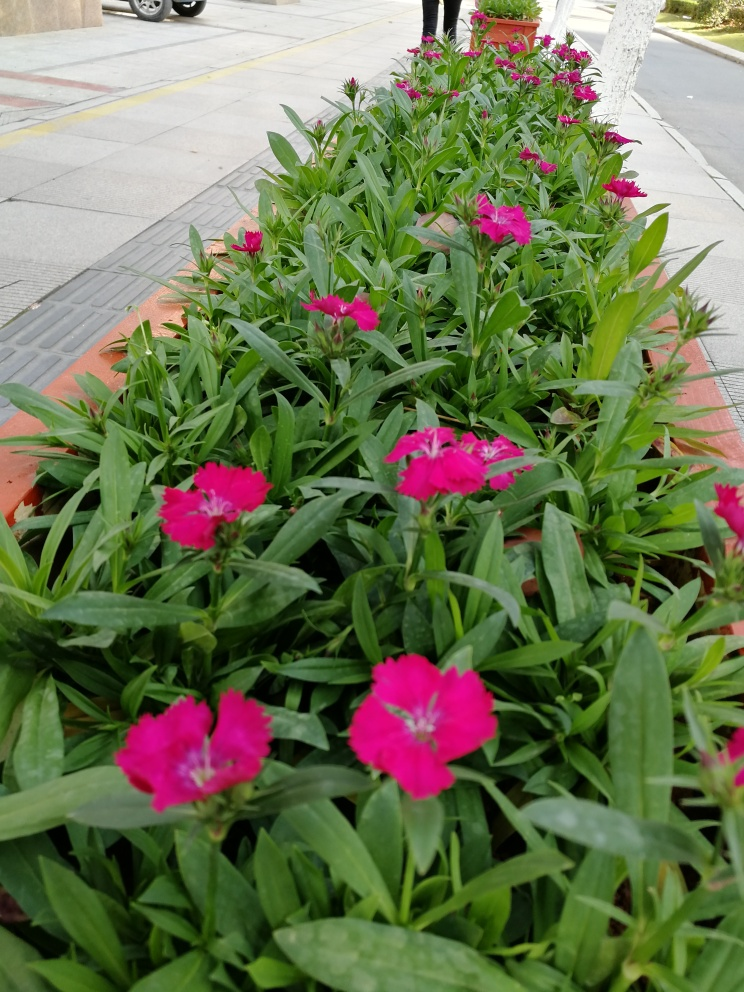How are the colors in this image?
A. The colors are monotonous.
B. The colors are vibrant.
C. The colors are dull.
Answer with the option's letter from the given choices directly.
 B. 